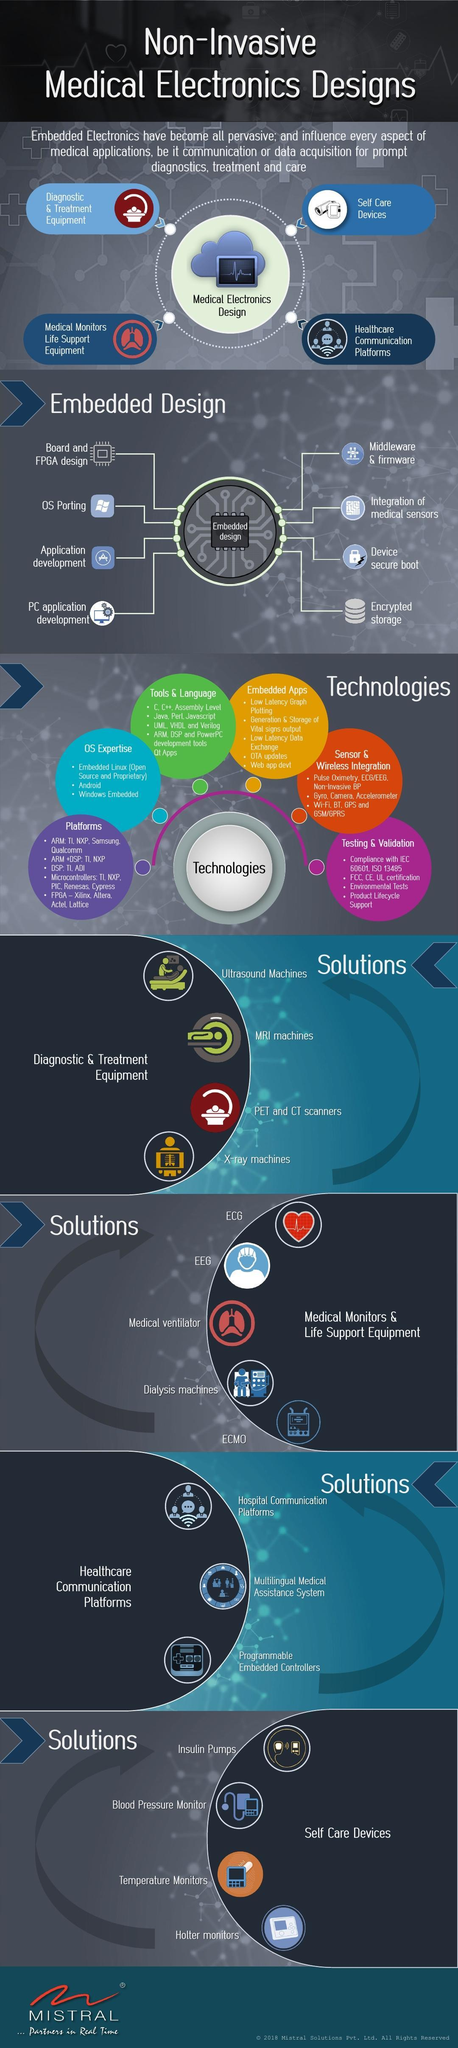How many medical monitors and life support systems are listed?
Answer the question with a short phrase. 5 How many types of technologies are applied to embedded design? 6 How many self care devices are listed ? 4 Which of these languages are used in embedded electronics, C, Python, Java, or C++? C, Java, C++ 